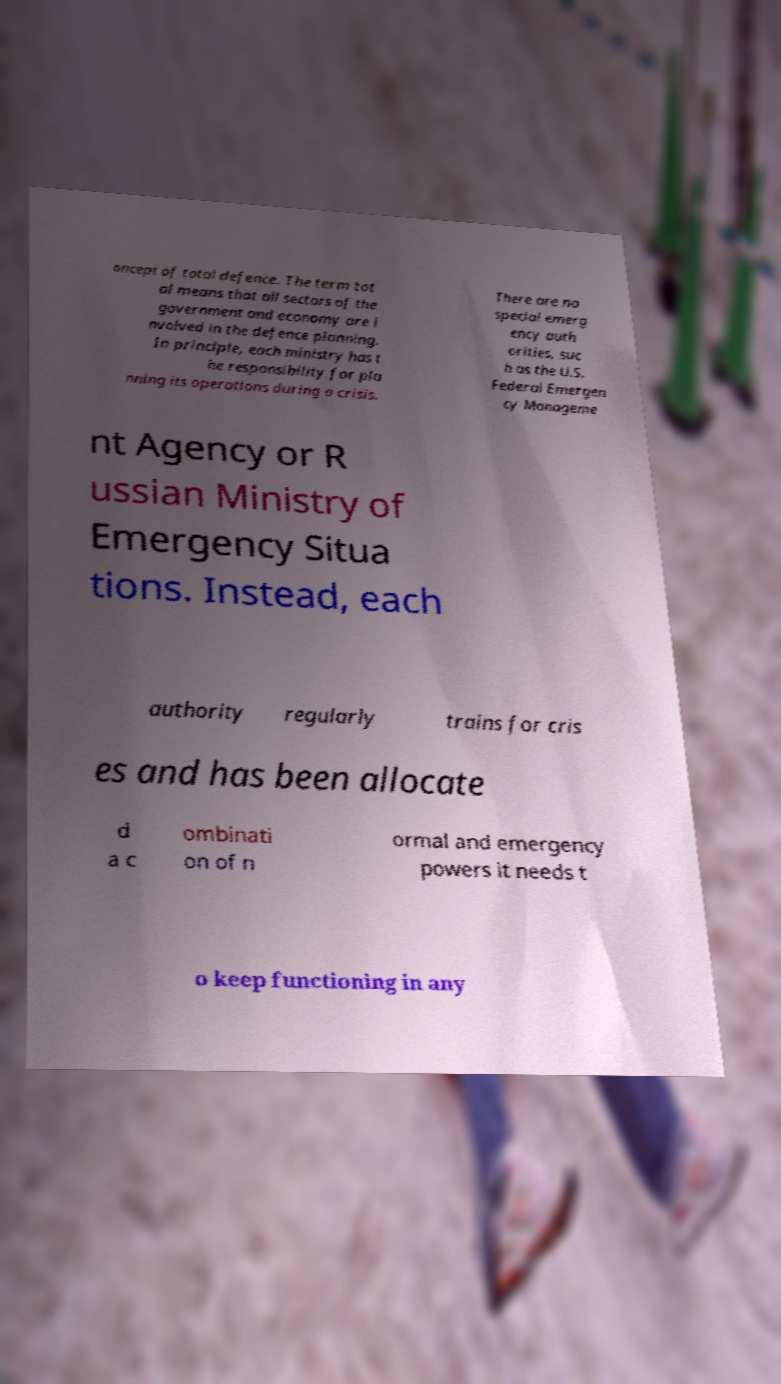Please identify and transcribe the text found in this image. oncept of total defence. The term tot al means that all sectors of the government and economy are i nvolved in the defence planning. In principle, each ministry has t he responsibility for pla nning its operations during a crisis. There are no special emerg ency auth orities, suc h as the U.S. Federal Emergen cy Manageme nt Agency or R ussian Ministry of Emergency Situa tions. Instead, each authority regularly trains for cris es and has been allocate d a c ombinati on of n ormal and emergency powers it needs t o keep functioning in any 